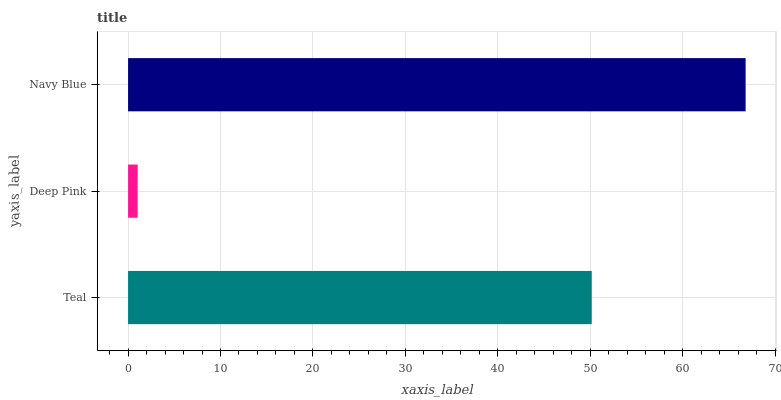Is Deep Pink the minimum?
Answer yes or no. Yes. Is Navy Blue the maximum?
Answer yes or no. Yes. Is Navy Blue the minimum?
Answer yes or no. No. Is Deep Pink the maximum?
Answer yes or no. No. Is Navy Blue greater than Deep Pink?
Answer yes or no. Yes. Is Deep Pink less than Navy Blue?
Answer yes or no. Yes. Is Deep Pink greater than Navy Blue?
Answer yes or no. No. Is Navy Blue less than Deep Pink?
Answer yes or no. No. Is Teal the high median?
Answer yes or no. Yes. Is Teal the low median?
Answer yes or no. Yes. Is Navy Blue the high median?
Answer yes or no. No. Is Deep Pink the low median?
Answer yes or no. No. 